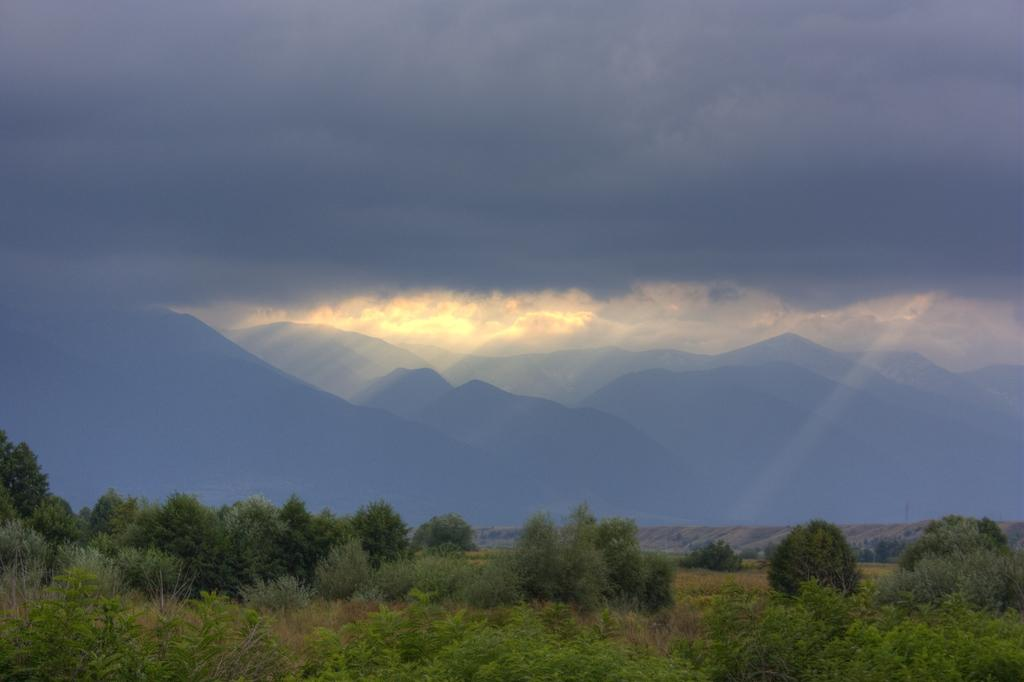What type of vegetation is visible in the image? There are trees in the image. What type of natural landform can be seen in the background of the image? There are mountains in the background of the image. What is the condition of the sky in the image? The sky is cloudy in the image. What is the name of the monkey sitting on the lamp in the image? There is no monkey or lamp present in the image. What type of creature is shown interacting with the lamp in the image? There is no creature shown interacting with a lamp in the image; only trees, mountains, and the sky are present. 